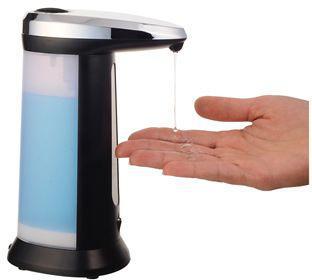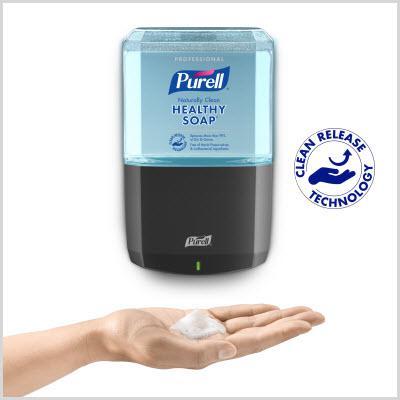The first image is the image on the left, the second image is the image on the right. Given the left and right images, does the statement "The left and right image contains a total of three wall soap dispensers." hold true? Answer yes or no. No. The first image is the image on the left, the second image is the image on the right. Evaluate the accuracy of this statement regarding the images: "An image shows a bottle of hand soap on the lower left, and at least two versions of the same style wall-mounted dispenser above it.". Is it true? Answer yes or no. No. 